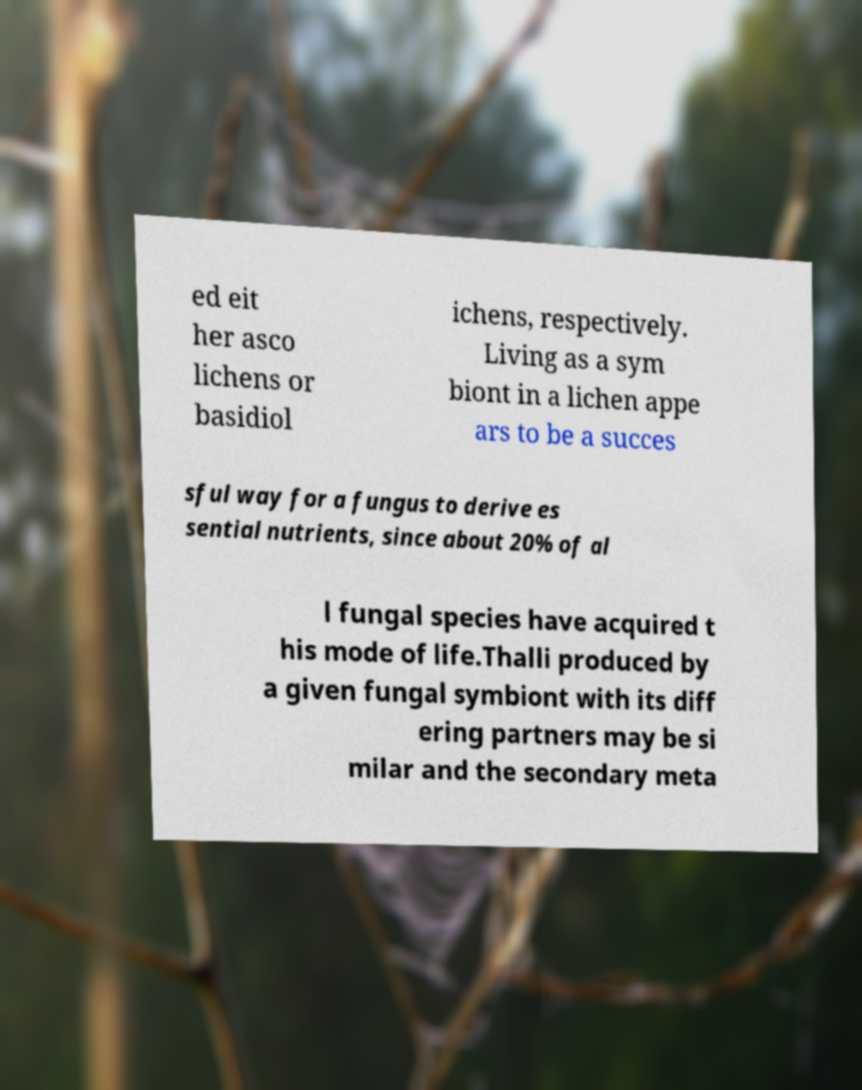Can you accurately transcribe the text from the provided image for me? ed eit her asco lichens or basidiol ichens, respectively. Living as a sym biont in a lichen appe ars to be a succes sful way for a fungus to derive es sential nutrients, since about 20% of al l fungal species have acquired t his mode of life.Thalli produced by a given fungal symbiont with its diff ering partners may be si milar and the secondary meta 